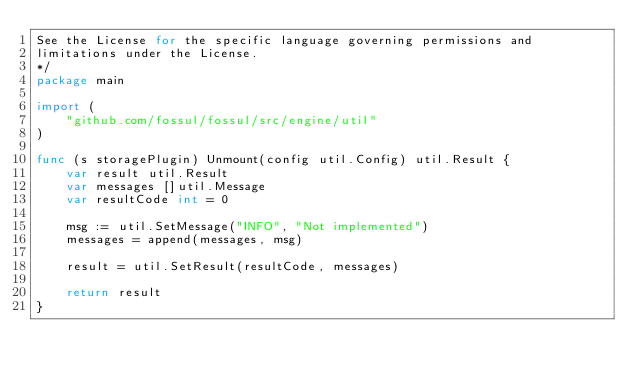Convert code to text. <code><loc_0><loc_0><loc_500><loc_500><_Go_>See the License for the specific language governing permissions and
limitations under the License.
*/
package main

import (
	"github.com/fossul/fossul/src/engine/util"
)

func (s storagePlugin) Unmount(config util.Config) util.Result {
	var result util.Result
	var messages []util.Message
	var resultCode int = 0

	msg := util.SetMessage("INFO", "Not implemented")
	messages = append(messages, msg)

	result = util.SetResult(resultCode, messages)

	return result
}
</code> 